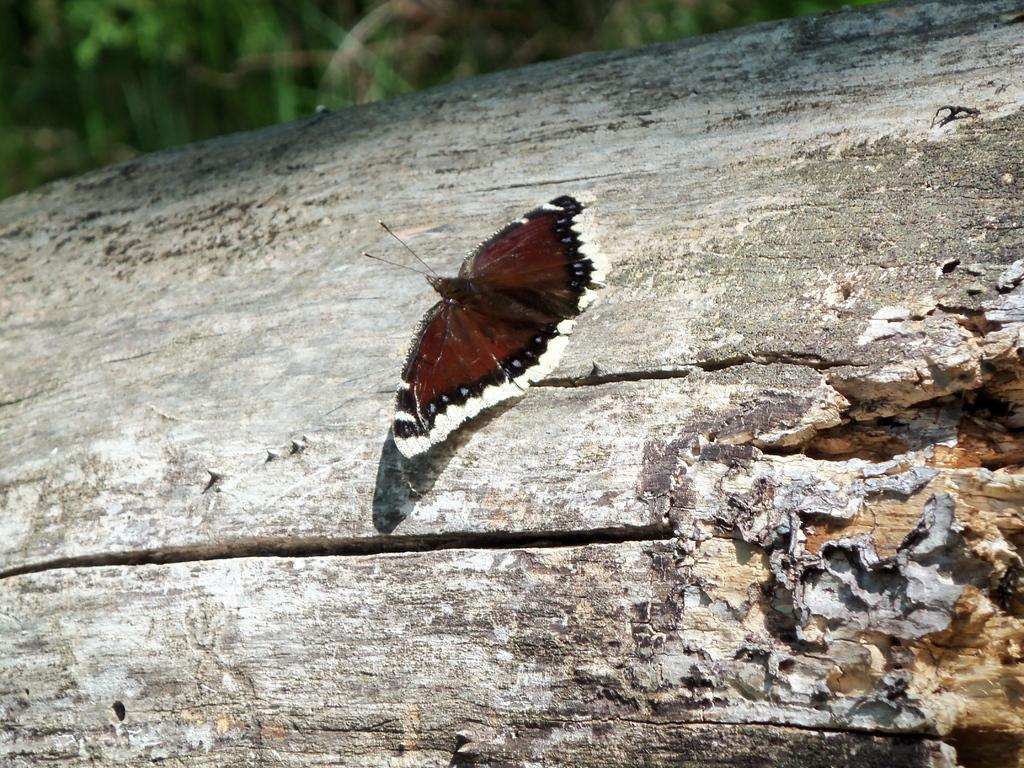What is the main subject of the picture? The main subject of the picture is a butterfly. What is the butterfly resting on? The butterfly is laying on a wooden surface. What color is the butterfly? The butterfly is brown in color. What type of railway can be seen in the picture? There is no railway present in the picture; it features a brown butterfly resting on a wooden surface. What color are the crayons in the picture? There are no crayons present in the picture. 